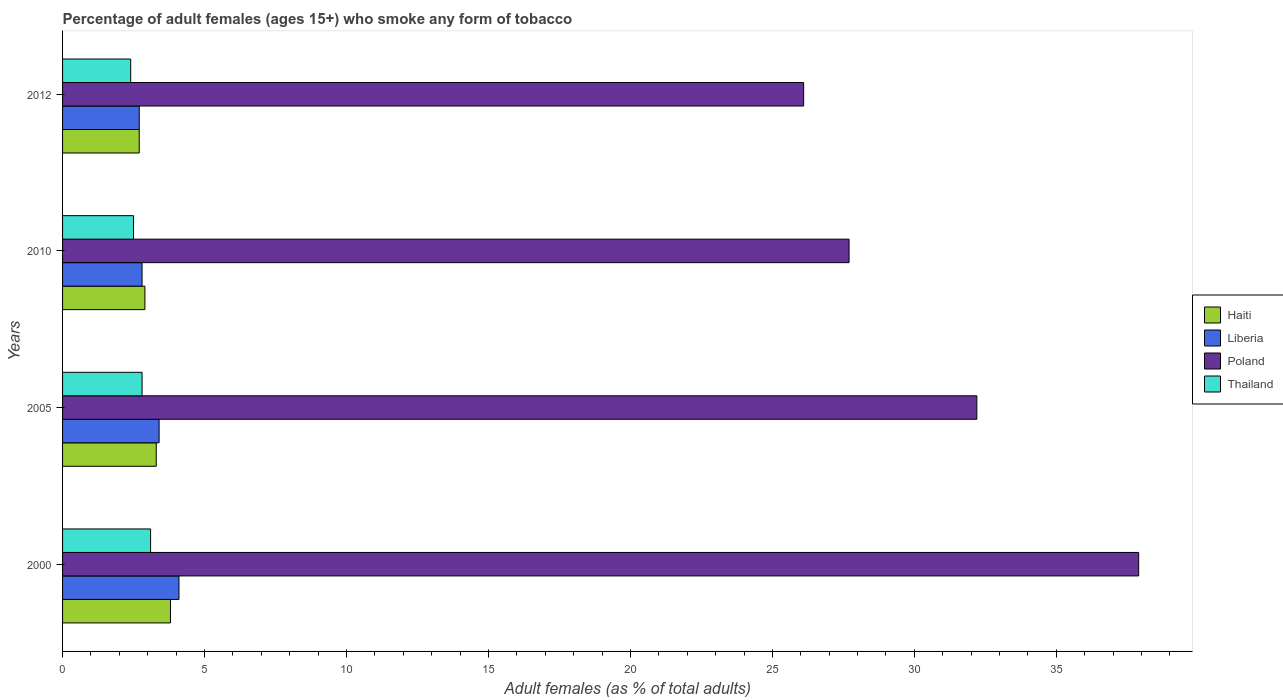Are the number of bars on each tick of the Y-axis equal?
Keep it short and to the point. Yes. What is the label of the 2nd group of bars from the top?
Offer a terse response. 2010. Across all years, what is the minimum percentage of adult females who smoke in Haiti?
Make the answer very short. 2.7. In which year was the percentage of adult females who smoke in Thailand minimum?
Keep it short and to the point. 2012. What is the total percentage of adult females who smoke in Thailand in the graph?
Your response must be concise. 10.8. What is the difference between the percentage of adult females who smoke in Poland in 2000 and that in 2012?
Give a very brief answer. 11.8. What is the difference between the percentage of adult females who smoke in Haiti in 2010 and the percentage of adult females who smoke in Liberia in 2000?
Make the answer very short. -1.2. What is the average percentage of adult females who smoke in Haiti per year?
Provide a succinct answer. 3.17. In the year 2005, what is the difference between the percentage of adult females who smoke in Thailand and percentage of adult females who smoke in Haiti?
Your answer should be compact. -0.5. In how many years, is the percentage of adult females who smoke in Haiti greater than 25 %?
Your response must be concise. 0. What is the ratio of the percentage of adult females who smoke in Thailand in 2000 to that in 2012?
Your response must be concise. 1.29. What is the difference between the highest and the second highest percentage of adult females who smoke in Poland?
Your answer should be compact. 5.7. What is the difference between the highest and the lowest percentage of adult females who smoke in Poland?
Provide a short and direct response. 11.8. In how many years, is the percentage of adult females who smoke in Liberia greater than the average percentage of adult females who smoke in Liberia taken over all years?
Provide a short and direct response. 2. What does the 3rd bar from the top in 2012 represents?
Offer a terse response. Liberia. What does the 2nd bar from the bottom in 2012 represents?
Your answer should be compact. Liberia. How many years are there in the graph?
Provide a succinct answer. 4. What is the difference between two consecutive major ticks on the X-axis?
Offer a terse response. 5. Are the values on the major ticks of X-axis written in scientific E-notation?
Keep it short and to the point. No. Does the graph contain grids?
Offer a very short reply. No. How are the legend labels stacked?
Your answer should be compact. Vertical. What is the title of the graph?
Offer a terse response. Percentage of adult females (ages 15+) who smoke any form of tobacco. What is the label or title of the X-axis?
Your response must be concise. Adult females (as % of total adults). What is the label or title of the Y-axis?
Your response must be concise. Years. What is the Adult females (as % of total adults) of Liberia in 2000?
Ensure brevity in your answer.  4.1. What is the Adult females (as % of total adults) of Poland in 2000?
Your answer should be very brief. 37.9. What is the Adult females (as % of total adults) of Thailand in 2000?
Keep it short and to the point. 3.1. What is the Adult females (as % of total adults) of Liberia in 2005?
Ensure brevity in your answer.  3.4. What is the Adult females (as % of total adults) in Poland in 2005?
Offer a terse response. 32.2. What is the Adult females (as % of total adults) in Thailand in 2005?
Your answer should be very brief. 2.8. What is the Adult females (as % of total adults) in Haiti in 2010?
Ensure brevity in your answer.  2.9. What is the Adult females (as % of total adults) of Liberia in 2010?
Make the answer very short. 2.8. What is the Adult females (as % of total adults) in Poland in 2010?
Provide a succinct answer. 27.7. What is the Adult females (as % of total adults) in Liberia in 2012?
Offer a terse response. 2.7. What is the Adult females (as % of total adults) in Poland in 2012?
Give a very brief answer. 26.1. Across all years, what is the maximum Adult females (as % of total adults) in Haiti?
Your answer should be very brief. 3.8. Across all years, what is the maximum Adult females (as % of total adults) of Poland?
Make the answer very short. 37.9. Across all years, what is the maximum Adult females (as % of total adults) of Thailand?
Offer a terse response. 3.1. Across all years, what is the minimum Adult females (as % of total adults) in Haiti?
Your answer should be compact. 2.7. Across all years, what is the minimum Adult females (as % of total adults) in Poland?
Your response must be concise. 26.1. Across all years, what is the minimum Adult females (as % of total adults) in Thailand?
Your answer should be very brief. 2.4. What is the total Adult females (as % of total adults) of Haiti in the graph?
Your answer should be very brief. 12.7. What is the total Adult females (as % of total adults) of Poland in the graph?
Keep it short and to the point. 123.9. What is the difference between the Adult females (as % of total adults) of Thailand in 2000 and that in 2005?
Ensure brevity in your answer.  0.3. What is the difference between the Adult females (as % of total adults) of Liberia in 2000 and that in 2010?
Offer a terse response. 1.3. What is the difference between the Adult females (as % of total adults) in Poland in 2000 and that in 2010?
Keep it short and to the point. 10.2. What is the difference between the Adult females (as % of total adults) of Thailand in 2000 and that in 2010?
Provide a short and direct response. 0.6. What is the difference between the Adult females (as % of total adults) of Haiti in 2000 and that in 2012?
Offer a terse response. 1.1. What is the difference between the Adult females (as % of total adults) of Thailand in 2000 and that in 2012?
Ensure brevity in your answer.  0.7. What is the difference between the Adult females (as % of total adults) of Haiti in 2005 and that in 2010?
Your response must be concise. 0.4. What is the difference between the Adult females (as % of total adults) in Liberia in 2005 and that in 2010?
Your response must be concise. 0.6. What is the difference between the Adult females (as % of total adults) of Poland in 2005 and that in 2010?
Your answer should be very brief. 4.5. What is the difference between the Adult females (as % of total adults) of Thailand in 2005 and that in 2010?
Provide a short and direct response. 0.3. What is the difference between the Adult females (as % of total adults) in Haiti in 2005 and that in 2012?
Your answer should be compact. 0.6. What is the difference between the Adult females (as % of total adults) of Liberia in 2005 and that in 2012?
Keep it short and to the point. 0.7. What is the difference between the Adult females (as % of total adults) of Haiti in 2010 and that in 2012?
Make the answer very short. 0.2. What is the difference between the Adult females (as % of total adults) of Liberia in 2010 and that in 2012?
Your answer should be compact. 0.1. What is the difference between the Adult females (as % of total adults) in Poland in 2010 and that in 2012?
Your answer should be very brief. 1.6. What is the difference between the Adult females (as % of total adults) in Thailand in 2010 and that in 2012?
Provide a succinct answer. 0.1. What is the difference between the Adult females (as % of total adults) of Haiti in 2000 and the Adult females (as % of total adults) of Poland in 2005?
Provide a short and direct response. -28.4. What is the difference between the Adult females (as % of total adults) of Haiti in 2000 and the Adult females (as % of total adults) of Thailand in 2005?
Your answer should be compact. 1. What is the difference between the Adult females (as % of total adults) of Liberia in 2000 and the Adult females (as % of total adults) of Poland in 2005?
Your answer should be compact. -28.1. What is the difference between the Adult females (as % of total adults) in Liberia in 2000 and the Adult females (as % of total adults) in Thailand in 2005?
Your response must be concise. 1.3. What is the difference between the Adult females (as % of total adults) in Poland in 2000 and the Adult females (as % of total adults) in Thailand in 2005?
Provide a succinct answer. 35.1. What is the difference between the Adult females (as % of total adults) in Haiti in 2000 and the Adult females (as % of total adults) in Liberia in 2010?
Give a very brief answer. 1. What is the difference between the Adult females (as % of total adults) of Haiti in 2000 and the Adult females (as % of total adults) of Poland in 2010?
Your answer should be compact. -23.9. What is the difference between the Adult females (as % of total adults) in Liberia in 2000 and the Adult females (as % of total adults) in Poland in 2010?
Your response must be concise. -23.6. What is the difference between the Adult females (as % of total adults) in Liberia in 2000 and the Adult females (as % of total adults) in Thailand in 2010?
Give a very brief answer. 1.6. What is the difference between the Adult females (as % of total adults) of Poland in 2000 and the Adult females (as % of total adults) of Thailand in 2010?
Your answer should be very brief. 35.4. What is the difference between the Adult females (as % of total adults) of Haiti in 2000 and the Adult females (as % of total adults) of Poland in 2012?
Keep it short and to the point. -22.3. What is the difference between the Adult females (as % of total adults) of Liberia in 2000 and the Adult females (as % of total adults) of Poland in 2012?
Give a very brief answer. -22. What is the difference between the Adult females (as % of total adults) of Poland in 2000 and the Adult females (as % of total adults) of Thailand in 2012?
Offer a very short reply. 35.5. What is the difference between the Adult females (as % of total adults) in Haiti in 2005 and the Adult females (as % of total adults) in Liberia in 2010?
Give a very brief answer. 0.5. What is the difference between the Adult females (as % of total adults) of Haiti in 2005 and the Adult females (as % of total adults) of Poland in 2010?
Ensure brevity in your answer.  -24.4. What is the difference between the Adult females (as % of total adults) of Haiti in 2005 and the Adult females (as % of total adults) of Thailand in 2010?
Offer a terse response. 0.8. What is the difference between the Adult females (as % of total adults) in Liberia in 2005 and the Adult females (as % of total adults) in Poland in 2010?
Your answer should be compact. -24.3. What is the difference between the Adult females (as % of total adults) in Poland in 2005 and the Adult females (as % of total adults) in Thailand in 2010?
Your answer should be very brief. 29.7. What is the difference between the Adult females (as % of total adults) in Haiti in 2005 and the Adult females (as % of total adults) in Poland in 2012?
Provide a short and direct response. -22.8. What is the difference between the Adult females (as % of total adults) in Liberia in 2005 and the Adult females (as % of total adults) in Poland in 2012?
Give a very brief answer. -22.7. What is the difference between the Adult females (as % of total adults) in Liberia in 2005 and the Adult females (as % of total adults) in Thailand in 2012?
Your answer should be compact. 1. What is the difference between the Adult females (as % of total adults) of Poland in 2005 and the Adult females (as % of total adults) of Thailand in 2012?
Make the answer very short. 29.8. What is the difference between the Adult females (as % of total adults) in Haiti in 2010 and the Adult females (as % of total adults) in Poland in 2012?
Provide a succinct answer. -23.2. What is the difference between the Adult females (as % of total adults) of Liberia in 2010 and the Adult females (as % of total adults) of Poland in 2012?
Give a very brief answer. -23.3. What is the difference between the Adult females (as % of total adults) of Liberia in 2010 and the Adult females (as % of total adults) of Thailand in 2012?
Your response must be concise. 0.4. What is the difference between the Adult females (as % of total adults) of Poland in 2010 and the Adult females (as % of total adults) of Thailand in 2012?
Give a very brief answer. 25.3. What is the average Adult females (as % of total adults) in Haiti per year?
Keep it short and to the point. 3.17. What is the average Adult females (as % of total adults) in Liberia per year?
Your response must be concise. 3.25. What is the average Adult females (as % of total adults) of Poland per year?
Offer a very short reply. 30.98. What is the average Adult females (as % of total adults) of Thailand per year?
Offer a very short reply. 2.7. In the year 2000, what is the difference between the Adult females (as % of total adults) of Haiti and Adult females (as % of total adults) of Poland?
Give a very brief answer. -34.1. In the year 2000, what is the difference between the Adult females (as % of total adults) in Liberia and Adult females (as % of total adults) in Poland?
Make the answer very short. -33.8. In the year 2000, what is the difference between the Adult females (as % of total adults) in Liberia and Adult females (as % of total adults) in Thailand?
Offer a very short reply. 1. In the year 2000, what is the difference between the Adult females (as % of total adults) of Poland and Adult females (as % of total adults) of Thailand?
Your answer should be compact. 34.8. In the year 2005, what is the difference between the Adult females (as % of total adults) of Haiti and Adult females (as % of total adults) of Liberia?
Keep it short and to the point. -0.1. In the year 2005, what is the difference between the Adult females (as % of total adults) in Haiti and Adult females (as % of total adults) in Poland?
Offer a very short reply. -28.9. In the year 2005, what is the difference between the Adult females (as % of total adults) of Haiti and Adult females (as % of total adults) of Thailand?
Provide a short and direct response. 0.5. In the year 2005, what is the difference between the Adult females (as % of total adults) of Liberia and Adult females (as % of total adults) of Poland?
Ensure brevity in your answer.  -28.8. In the year 2005, what is the difference between the Adult females (as % of total adults) in Liberia and Adult females (as % of total adults) in Thailand?
Provide a short and direct response. 0.6. In the year 2005, what is the difference between the Adult females (as % of total adults) in Poland and Adult females (as % of total adults) in Thailand?
Ensure brevity in your answer.  29.4. In the year 2010, what is the difference between the Adult females (as % of total adults) of Haiti and Adult females (as % of total adults) of Poland?
Provide a succinct answer. -24.8. In the year 2010, what is the difference between the Adult females (as % of total adults) of Liberia and Adult females (as % of total adults) of Poland?
Ensure brevity in your answer.  -24.9. In the year 2010, what is the difference between the Adult females (as % of total adults) in Poland and Adult females (as % of total adults) in Thailand?
Ensure brevity in your answer.  25.2. In the year 2012, what is the difference between the Adult females (as % of total adults) in Haiti and Adult females (as % of total adults) in Poland?
Offer a very short reply. -23.4. In the year 2012, what is the difference between the Adult females (as % of total adults) in Haiti and Adult females (as % of total adults) in Thailand?
Provide a succinct answer. 0.3. In the year 2012, what is the difference between the Adult females (as % of total adults) of Liberia and Adult females (as % of total adults) of Poland?
Give a very brief answer. -23.4. In the year 2012, what is the difference between the Adult females (as % of total adults) in Liberia and Adult females (as % of total adults) in Thailand?
Provide a short and direct response. 0.3. In the year 2012, what is the difference between the Adult females (as % of total adults) in Poland and Adult females (as % of total adults) in Thailand?
Your answer should be very brief. 23.7. What is the ratio of the Adult females (as % of total adults) of Haiti in 2000 to that in 2005?
Keep it short and to the point. 1.15. What is the ratio of the Adult females (as % of total adults) of Liberia in 2000 to that in 2005?
Provide a short and direct response. 1.21. What is the ratio of the Adult females (as % of total adults) in Poland in 2000 to that in 2005?
Your answer should be compact. 1.18. What is the ratio of the Adult females (as % of total adults) in Thailand in 2000 to that in 2005?
Provide a succinct answer. 1.11. What is the ratio of the Adult females (as % of total adults) in Haiti in 2000 to that in 2010?
Your answer should be very brief. 1.31. What is the ratio of the Adult females (as % of total adults) of Liberia in 2000 to that in 2010?
Your answer should be compact. 1.46. What is the ratio of the Adult females (as % of total adults) in Poland in 2000 to that in 2010?
Keep it short and to the point. 1.37. What is the ratio of the Adult females (as % of total adults) in Thailand in 2000 to that in 2010?
Your answer should be very brief. 1.24. What is the ratio of the Adult females (as % of total adults) of Haiti in 2000 to that in 2012?
Make the answer very short. 1.41. What is the ratio of the Adult females (as % of total adults) of Liberia in 2000 to that in 2012?
Provide a short and direct response. 1.52. What is the ratio of the Adult females (as % of total adults) of Poland in 2000 to that in 2012?
Give a very brief answer. 1.45. What is the ratio of the Adult females (as % of total adults) of Thailand in 2000 to that in 2012?
Make the answer very short. 1.29. What is the ratio of the Adult females (as % of total adults) of Haiti in 2005 to that in 2010?
Provide a short and direct response. 1.14. What is the ratio of the Adult females (as % of total adults) of Liberia in 2005 to that in 2010?
Make the answer very short. 1.21. What is the ratio of the Adult females (as % of total adults) in Poland in 2005 to that in 2010?
Your response must be concise. 1.16. What is the ratio of the Adult females (as % of total adults) in Thailand in 2005 to that in 2010?
Provide a succinct answer. 1.12. What is the ratio of the Adult females (as % of total adults) of Haiti in 2005 to that in 2012?
Your answer should be very brief. 1.22. What is the ratio of the Adult females (as % of total adults) of Liberia in 2005 to that in 2012?
Your response must be concise. 1.26. What is the ratio of the Adult females (as % of total adults) in Poland in 2005 to that in 2012?
Ensure brevity in your answer.  1.23. What is the ratio of the Adult females (as % of total adults) in Haiti in 2010 to that in 2012?
Your answer should be compact. 1.07. What is the ratio of the Adult females (as % of total adults) in Liberia in 2010 to that in 2012?
Offer a very short reply. 1.04. What is the ratio of the Adult females (as % of total adults) of Poland in 2010 to that in 2012?
Offer a terse response. 1.06. What is the ratio of the Adult females (as % of total adults) of Thailand in 2010 to that in 2012?
Provide a short and direct response. 1.04. What is the difference between the highest and the second highest Adult females (as % of total adults) of Haiti?
Your response must be concise. 0.5. What is the difference between the highest and the second highest Adult females (as % of total adults) in Poland?
Your answer should be very brief. 5.7. What is the difference between the highest and the lowest Adult females (as % of total adults) in Haiti?
Give a very brief answer. 1.1. What is the difference between the highest and the lowest Adult females (as % of total adults) in Poland?
Ensure brevity in your answer.  11.8. What is the difference between the highest and the lowest Adult females (as % of total adults) in Thailand?
Ensure brevity in your answer.  0.7. 